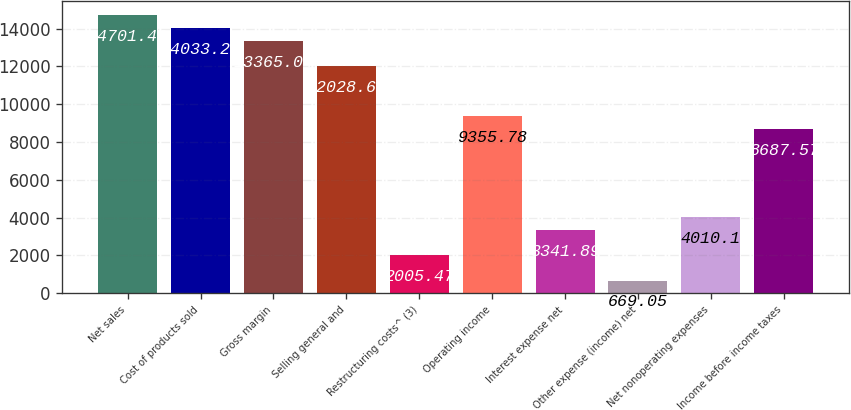Convert chart to OTSL. <chart><loc_0><loc_0><loc_500><loc_500><bar_chart><fcel>Net sales<fcel>Cost of products sold<fcel>Gross margin<fcel>Selling general and<fcel>Restructuring costs^ (3)<fcel>Operating income<fcel>Interest expense net<fcel>Other expense (income) net<fcel>Net nonoperating expenses<fcel>Income before income taxes<nl><fcel>14701.5<fcel>14033.2<fcel>13365<fcel>12028.6<fcel>2005.47<fcel>9355.78<fcel>3341.89<fcel>669.05<fcel>4010.1<fcel>8687.57<nl></chart> 